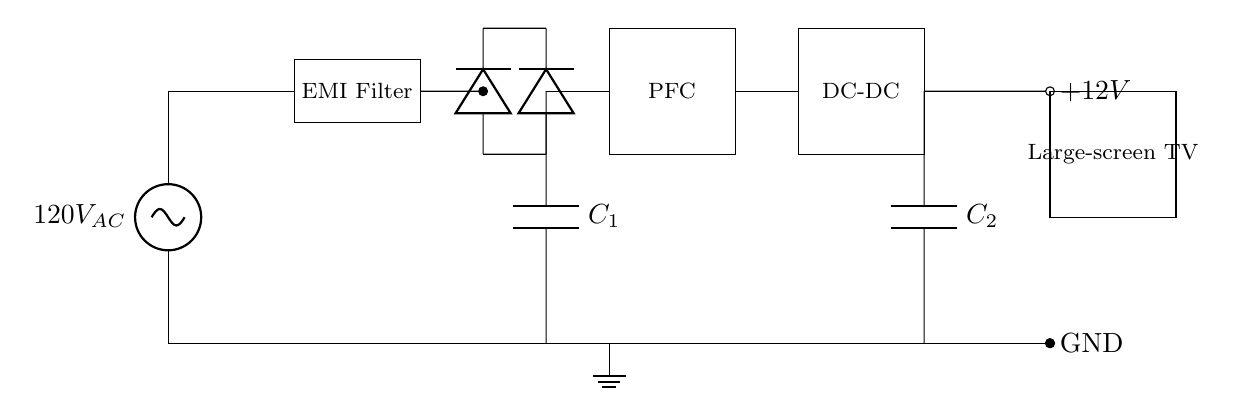What type of circuit is shown? The circuit is a power supply circuit, specifically designed for a high-power appliance like a large-screen TV. This is indicated by components such as the EMI filter, rectifier, and converters which all cater to power management.
Answer: Power supply circuit What is the AC voltage input to the circuit? The circuit shows an AC voltage source labeled 120V AC at the entry point of the power supply. This is the voltage that supplies power to the circuit.
Answer: 120V AC What does the smoothing capacitor do? The smoothing capacitor, labeled C1, helps stabilize the DC voltage after rectification. It charges when the voltage rises and discharges when it falls, thus smoothing out fluctuations in the DC output.
Answer: Stabilizes voltage How many diodes are present in the circuit? There are four diodes used in the bridge rectifier section of the circuit, which allows for conversion of AC to DC. This arrangement is typical for enabling current to flow in both directions from the AC supply.
Answer: Four diodes What is the output voltage from the circuit? The circuit features an output labeled +12V, which indicates the voltage provided to the load, specifically the large-screen TV. This voltage is necessary to power the device effectively.
Answer: 12V Why is power factor correction included in the circuit? Power factor correction (PFC) is included to improve the efficiency of the power supply by minimizing the phase difference between voltage and current. This is essential in high-power applications to reduce wasted energy.
Answer: Improve efficiency What is the purpose of the EMI filter in this circuit? The EMI filter is employed to reduce electromagnetic interference that might affect the operation of other nearby devices as well as ensure clean power supply to the connected appliance. This is crucial for the performance of sensitive electronics like TVs.
Answer: Reduce interference 